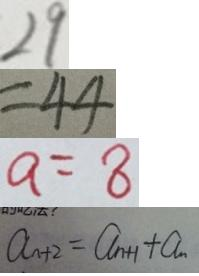<formula> <loc_0><loc_0><loc_500><loc_500>2 9 
 = 4 4 
 a = 8 
 a _ { n + 2 } = a _ { n + 1 } + a _ { n }</formula> 